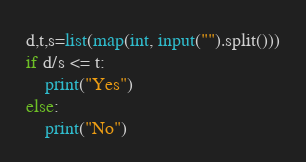Convert code to text. <code><loc_0><loc_0><loc_500><loc_500><_Python_>d,t,s=list(map(int, input("").split()))
if d/s <= t:
    print("Yes")
else:
    print("No")</code> 